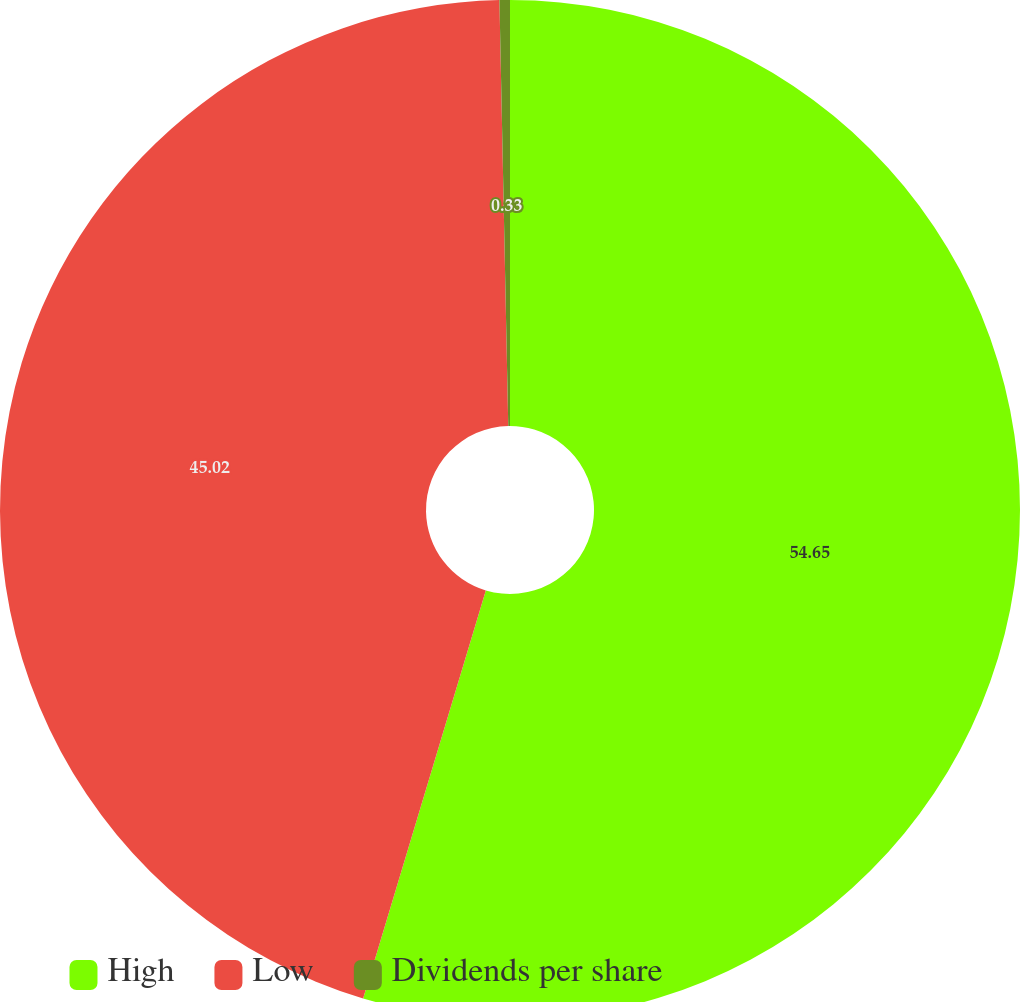Convert chart to OTSL. <chart><loc_0><loc_0><loc_500><loc_500><pie_chart><fcel>High<fcel>Low<fcel>Dividends per share<nl><fcel>54.65%<fcel>45.02%<fcel>0.33%<nl></chart> 